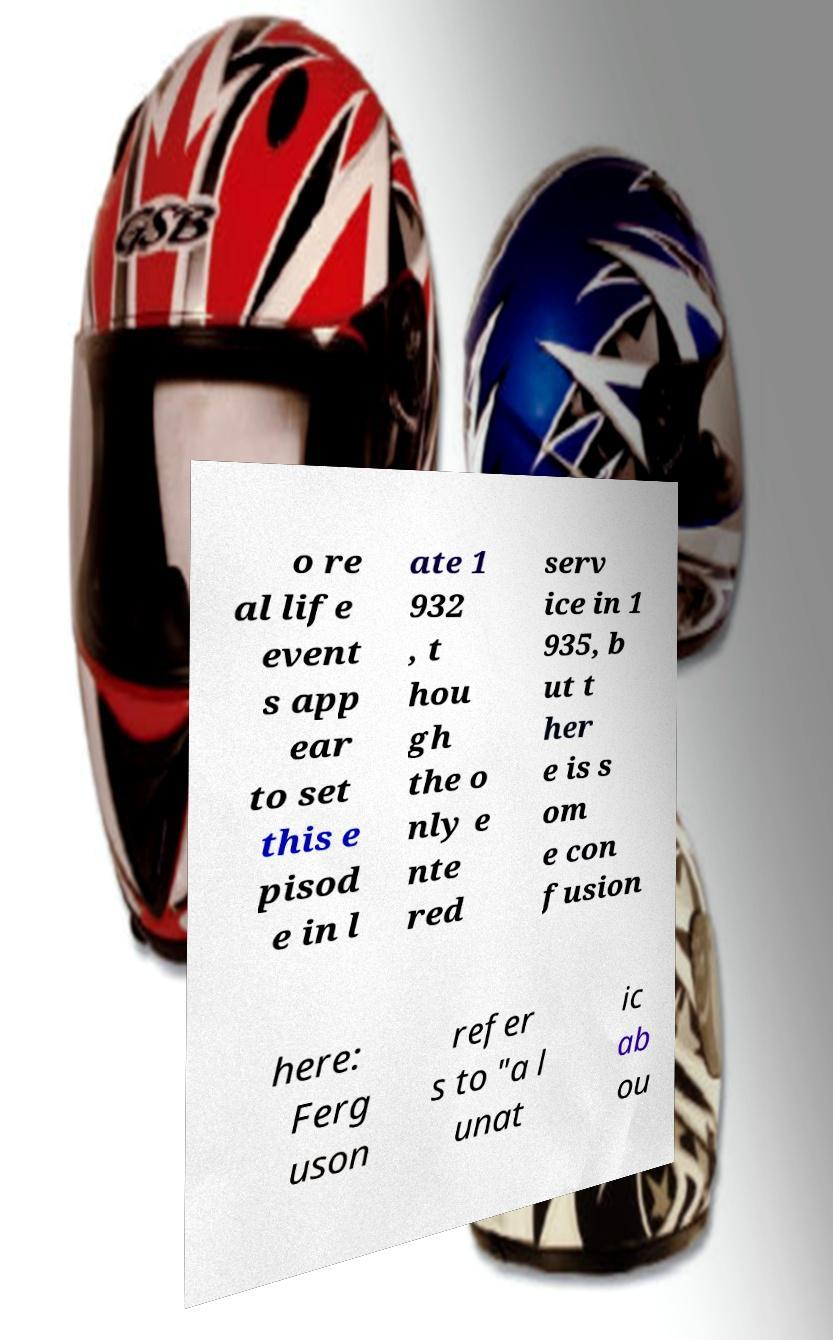Can you accurately transcribe the text from the provided image for me? o re al life event s app ear to set this e pisod e in l ate 1 932 , t hou gh the o nly e nte red serv ice in 1 935, b ut t her e is s om e con fusion here: Ferg uson refer s to "a l unat ic ab ou 